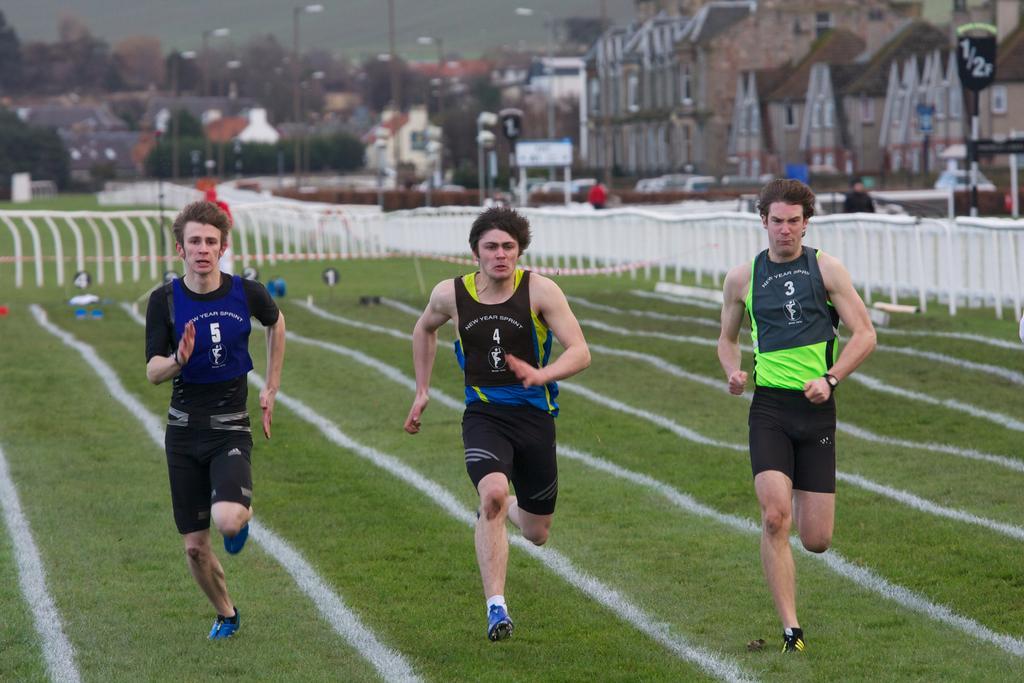How would you summarize this image in a sentence or two? In this image I can see an open grass ground and on it I can see three men are running. I can see all of them are wearing sports jerseys, shoes and on their jerseys I can see something is written. In the background I can see number of white colour iron poles, few things on the ground, few boards, number of poles, number of street lights, number of trees, number of buildings, few boards, few people and on these words I can see something is written. On the top left side of the image I can see the sky and I can also see this image is little bit blurry in the background. 